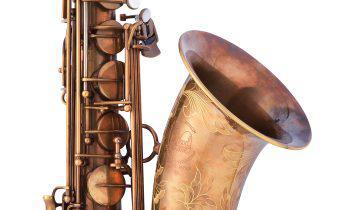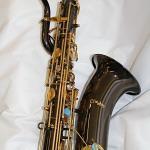The first image is the image on the left, the second image is the image on the right. Given the left and right images, does the statement "The saxophone in the image on the left is on a stand." hold true? Answer yes or no. No. 